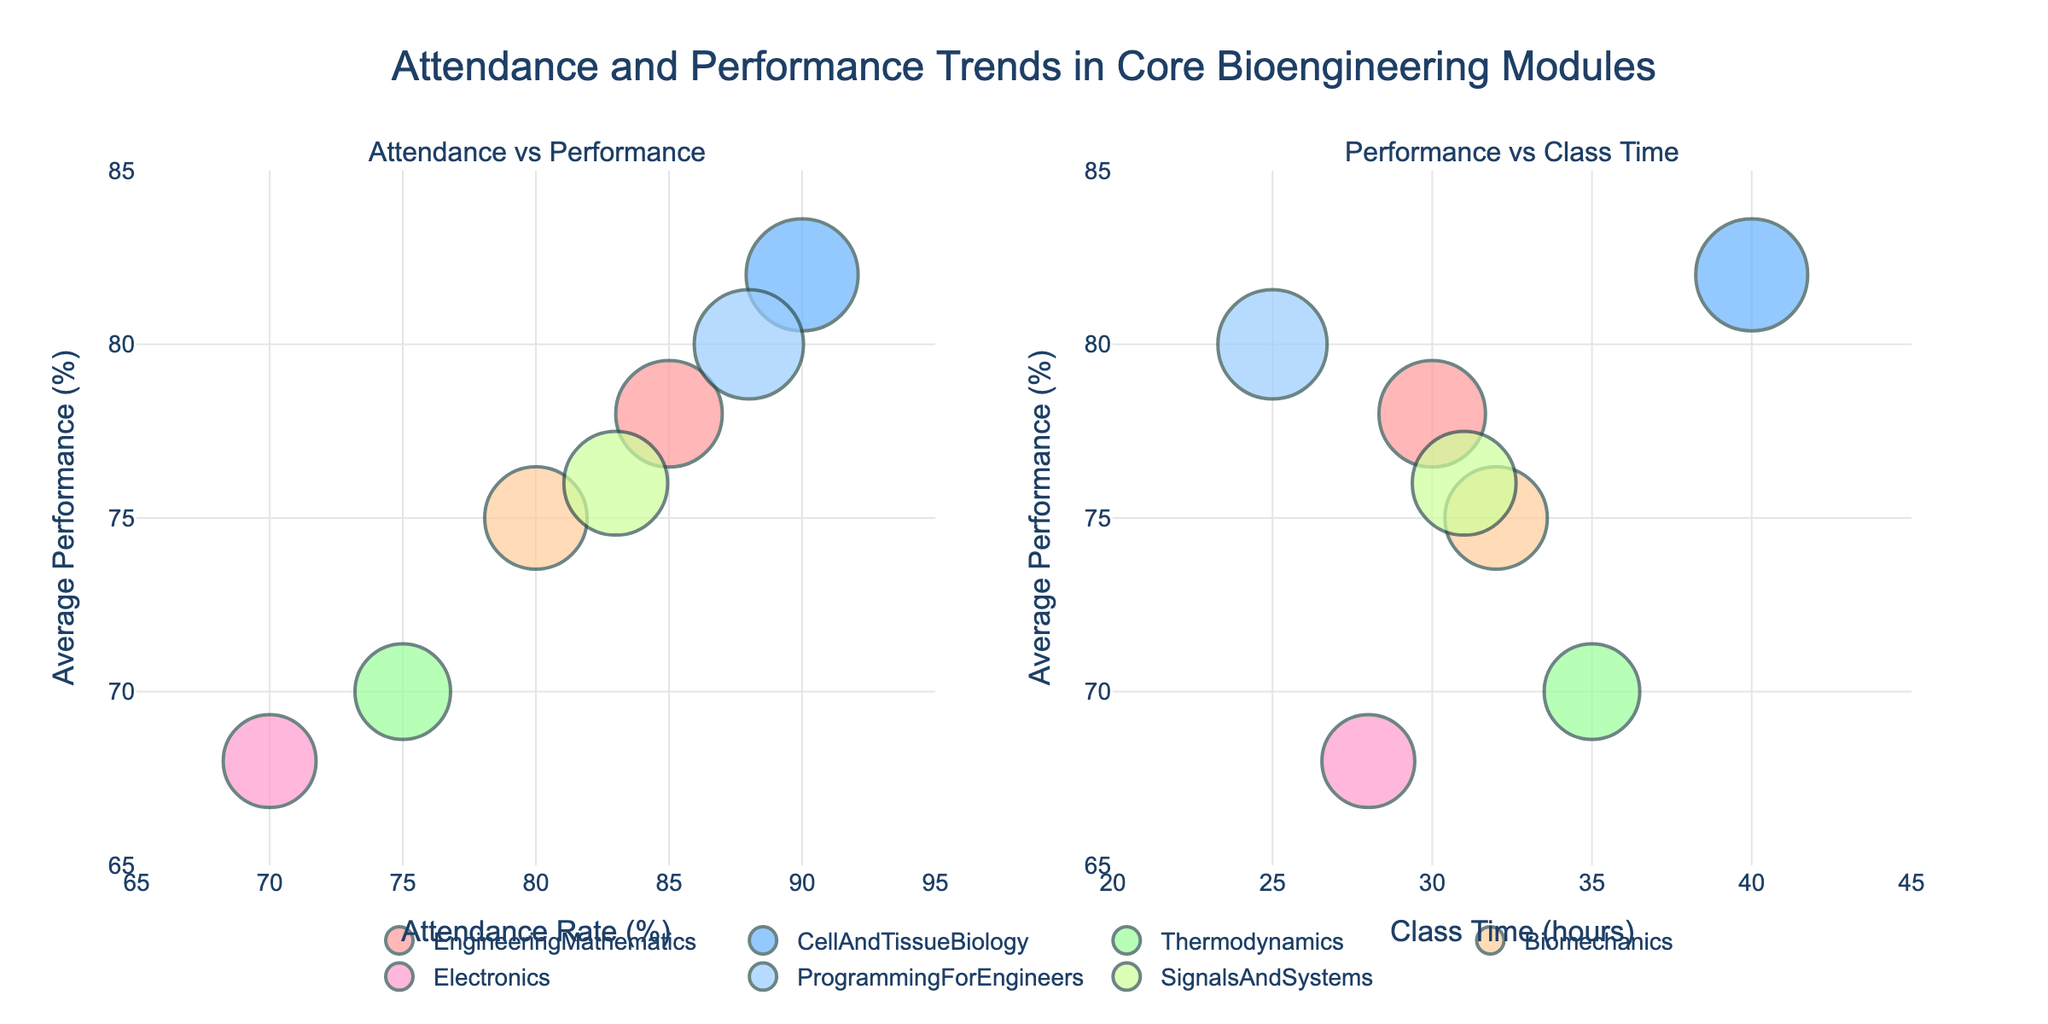What is the title of the figure? The title is located at the top of the figure and describes the overall content, which is "Attendance and Performance Trends in Core Bioengineering Modules".
Answer: Attendance and Performance Trends in Core Bioengineering Modules Which module has the highest attendance rate? By looking at the "Attendance vs Performance" subplot on the x-axis representing attendance rates, the highest value is associated with "CellAndTissueBiology" which has an attendance rate of 90%.
Answer: CellAndTissueBiology How many modules have an average performance rate below 75%? By analyzing the y-axis on both subplots which represents average performance, two modules, "Thermodynamics" and "Electronics", are below the 75% average performance mark.
Answer: 2 What is the correlation between attendance rate and average performance? The "Attendance vs Performance" subplot shows that modules with higher attendance rates generally have higher average performance rates, indicating a positive correlation.
Answer: Positive correlation Which module has the smallest bubble size in the "Performance vs Class Time" subplot? The bubble sizes represent average performance rates, so the module with the smallest size in the "Performance vs Class Time" subplot is "Electronics" with a performance rate of 68%.
Answer: Electronics What is the class time for the module with the highest average performance? By looking at the "Performance vs Class Time" subplot, "CellAndTissueBiology" has the highest performance (82%), and its class time is 40 hours.
Answer: 40 hours Which module has the closest attendance rate to its average performance? In the "Attendance vs Performance" subplot, "ProgrammingForEngineers" has an attendance rate of 88% and an average performance of 80%, having the closest values among other modules.
Answer: ProgrammingForEngineers Between "SignalsAndSystems" and "Biomechanics", which module has a higher average performance and by how much? By looking at both subplots, "SignalsAndSystems" has an average performance of 76%, while "Biomechanics" has 75%. The difference is 76% - 75% = 1%.
Answer: SignalsAndSystems by 1% What is the range of class time hours in the figure? Looking at the x-axis of the "Performance vs Class Time" subplot, class time hours range from 25 to 40 hours.
Answer: 25 to 40 hours Which module shows the largest discrepancy between attendance rate and average performance? By comparing both subplots, "Electronics" has an attendance rate of 70% and an average performance of 68%, giving it the smallest discrepancy.
Answer: Electronics 